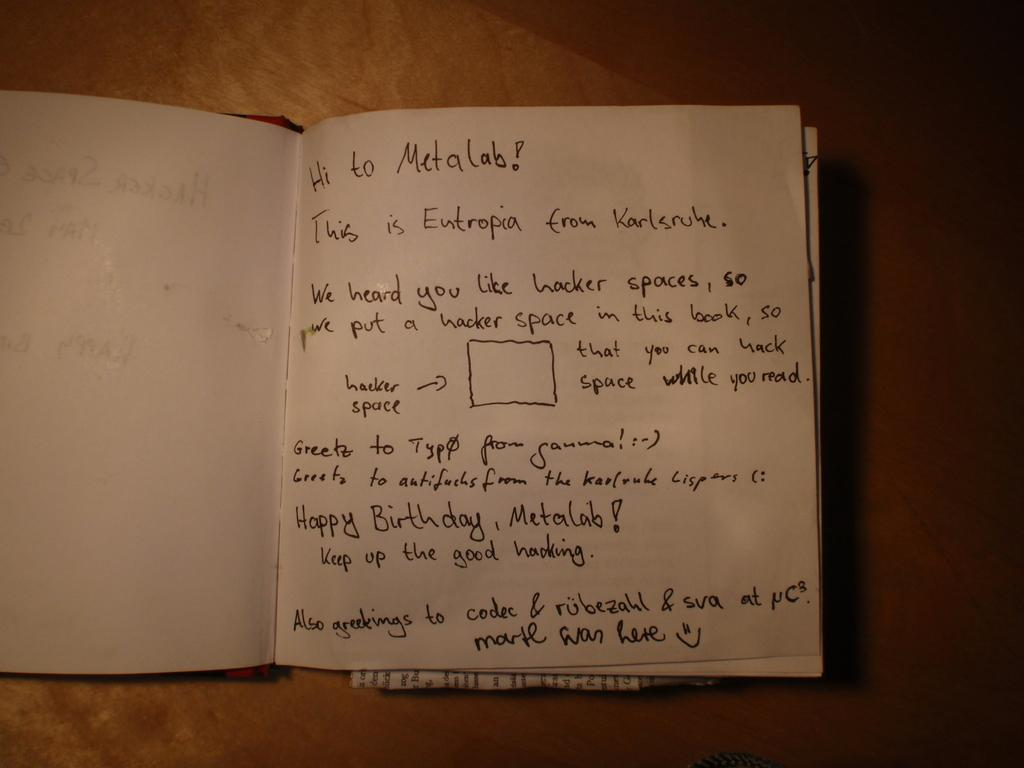<image>
Share a concise interpretation of the image provided. A person named Eutropia has written a birthday message to Metalab and wants them to keep up with the good hacking. 